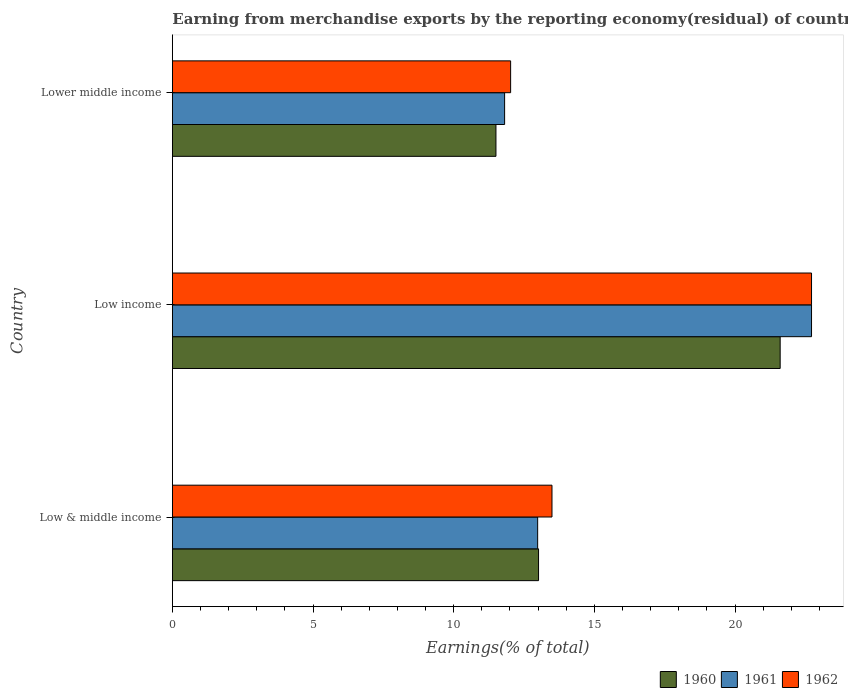How many groups of bars are there?
Give a very brief answer. 3. How many bars are there on the 3rd tick from the bottom?
Give a very brief answer. 3. In how many cases, is the number of bars for a given country not equal to the number of legend labels?
Your response must be concise. 0. What is the percentage of amount earned from merchandise exports in 1962 in Low & middle income?
Ensure brevity in your answer.  13.49. Across all countries, what is the maximum percentage of amount earned from merchandise exports in 1961?
Give a very brief answer. 22.72. Across all countries, what is the minimum percentage of amount earned from merchandise exports in 1962?
Your answer should be compact. 12.02. In which country was the percentage of amount earned from merchandise exports in 1960 minimum?
Offer a terse response. Lower middle income. What is the total percentage of amount earned from merchandise exports in 1961 in the graph?
Ensure brevity in your answer.  47.52. What is the difference between the percentage of amount earned from merchandise exports in 1961 in Low & middle income and that in Lower middle income?
Keep it short and to the point. 1.17. What is the difference between the percentage of amount earned from merchandise exports in 1962 in Low & middle income and the percentage of amount earned from merchandise exports in 1960 in Low income?
Offer a terse response. -8.11. What is the average percentage of amount earned from merchandise exports in 1960 per country?
Your response must be concise. 15.37. What is the difference between the percentage of amount earned from merchandise exports in 1960 and percentage of amount earned from merchandise exports in 1961 in Low & middle income?
Provide a short and direct response. 0.03. What is the ratio of the percentage of amount earned from merchandise exports in 1960 in Low & middle income to that in Low income?
Offer a very short reply. 0.6. Is the percentage of amount earned from merchandise exports in 1961 in Low income less than that in Lower middle income?
Your answer should be compact. No. What is the difference between the highest and the second highest percentage of amount earned from merchandise exports in 1960?
Your answer should be very brief. 8.59. What is the difference between the highest and the lowest percentage of amount earned from merchandise exports in 1960?
Offer a terse response. 10.1. What does the 3rd bar from the top in Lower middle income represents?
Keep it short and to the point. 1960. What does the 1st bar from the bottom in Low income represents?
Provide a short and direct response. 1960. How many bars are there?
Your answer should be compact. 9. What is the difference between two consecutive major ticks on the X-axis?
Provide a succinct answer. 5. Does the graph contain any zero values?
Give a very brief answer. No. Does the graph contain grids?
Your response must be concise. No. Where does the legend appear in the graph?
Make the answer very short. Bottom right. How many legend labels are there?
Offer a terse response. 3. What is the title of the graph?
Offer a very short reply. Earning from merchandise exports by the reporting economy(residual) of countries. What is the label or title of the X-axis?
Your response must be concise. Earnings(% of total). What is the Earnings(% of total) in 1960 in Low & middle income?
Make the answer very short. 13.02. What is the Earnings(% of total) of 1961 in Low & middle income?
Your answer should be very brief. 12.99. What is the Earnings(% of total) in 1962 in Low & middle income?
Provide a short and direct response. 13.49. What is the Earnings(% of total) in 1960 in Low income?
Ensure brevity in your answer.  21.61. What is the Earnings(% of total) of 1961 in Low income?
Provide a succinct answer. 22.72. What is the Earnings(% of total) of 1962 in Low income?
Make the answer very short. 22.72. What is the Earnings(% of total) of 1960 in Lower middle income?
Offer a terse response. 11.5. What is the Earnings(% of total) in 1961 in Lower middle income?
Ensure brevity in your answer.  11.81. What is the Earnings(% of total) of 1962 in Lower middle income?
Make the answer very short. 12.02. Across all countries, what is the maximum Earnings(% of total) in 1960?
Offer a very short reply. 21.61. Across all countries, what is the maximum Earnings(% of total) in 1961?
Offer a very short reply. 22.72. Across all countries, what is the maximum Earnings(% of total) of 1962?
Offer a terse response. 22.72. Across all countries, what is the minimum Earnings(% of total) in 1960?
Make the answer very short. 11.5. Across all countries, what is the minimum Earnings(% of total) in 1961?
Provide a short and direct response. 11.81. Across all countries, what is the minimum Earnings(% of total) in 1962?
Offer a terse response. 12.02. What is the total Earnings(% of total) of 1960 in the graph?
Your answer should be very brief. 46.12. What is the total Earnings(% of total) of 1961 in the graph?
Offer a terse response. 47.52. What is the total Earnings(% of total) in 1962 in the graph?
Your answer should be compact. 48.24. What is the difference between the Earnings(% of total) of 1960 in Low & middle income and that in Low income?
Provide a short and direct response. -8.59. What is the difference between the Earnings(% of total) of 1961 in Low & middle income and that in Low income?
Ensure brevity in your answer.  -9.74. What is the difference between the Earnings(% of total) in 1962 in Low & middle income and that in Low income?
Give a very brief answer. -9.23. What is the difference between the Earnings(% of total) in 1960 in Low & middle income and that in Lower middle income?
Ensure brevity in your answer.  1.51. What is the difference between the Earnings(% of total) of 1961 in Low & middle income and that in Lower middle income?
Offer a terse response. 1.17. What is the difference between the Earnings(% of total) of 1962 in Low & middle income and that in Lower middle income?
Your answer should be compact. 1.47. What is the difference between the Earnings(% of total) of 1960 in Low income and that in Lower middle income?
Your answer should be compact. 10.1. What is the difference between the Earnings(% of total) of 1961 in Low income and that in Lower middle income?
Your answer should be very brief. 10.91. What is the difference between the Earnings(% of total) in 1962 in Low income and that in Lower middle income?
Ensure brevity in your answer.  10.7. What is the difference between the Earnings(% of total) in 1960 in Low & middle income and the Earnings(% of total) in 1961 in Low income?
Give a very brief answer. -9.7. What is the difference between the Earnings(% of total) in 1960 in Low & middle income and the Earnings(% of total) in 1962 in Low income?
Your answer should be compact. -9.7. What is the difference between the Earnings(% of total) in 1961 in Low & middle income and the Earnings(% of total) in 1962 in Low income?
Give a very brief answer. -9.74. What is the difference between the Earnings(% of total) of 1960 in Low & middle income and the Earnings(% of total) of 1961 in Lower middle income?
Make the answer very short. 1.21. What is the difference between the Earnings(% of total) in 1961 in Low & middle income and the Earnings(% of total) in 1962 in Lower middle income?
Your answer should be very brief. 0.96. What is the difference between the Earnings(% of total) of 1960 in Low income and the Earnings(% of total) of 1961 in Lower middle income?
Provide a short and direct response. 9.8. What is the difference between the Earnings(% of total) of 1960 in Low income and the Earnings(% of total) of 1962 in Lower middle income?
Provide a short and direct response. 9.58. What is the difference between the Earnings(% of total) in 1961 in Low income and the Earnings(% of total) in 1962 in Lower middle income?
Your answer should be very brief. 10.7. What is the average Earnings(% of total) of 1960 per country?
Provide a short and direct response. 15.38. What is the average Earnings(% of total) in 1961 per country?
Offer a terse response. 15.84. What is the average Earnings(% of total) of 1962 per country?
Your answer should be very brief. 16.08. What is the difference between the Earnings(% of total) in 1960 and Earnings(% of total) in 1961 in Low & middle income?
Your response must be concise. 0.03. What is the difference between the Earnings(% of total) of 1960 and Earnings(% of total) of 1962 in Low & middle income?
Provide a short and direct response. -0.48. What is the difference between the Earnings(% of total) of 1961 and Earnings(% of total) of 1962 in Low & middle income?
Your answer should be compact. -0.51. What is the difference between the Earnings(% of total) of 1960 and Earnings(% of total) of 1961 in Low income?
Provide a succinct answer. -1.11. What is the difference between the Earnings(% of total) of 1960 and Earnings(% of total) of 1962 in Low income?
Provide a succinct answer. -1.12. What is the difference between the Earnings(% of total) in 1961 and Earnings(% of total) in 1962 in Low income?
Give a very brief answer. -0. What is the difference between the Earnings(% of total) in 1960 and Earnings(% of total) in 1961 in Lower middle income?
Provide a succinct answer. -0.31. What is the difference between the Earnings(% of total) of 1960 and Earnings(% of total) of 1962 in Lower middle income?
Your answer should be compact. -0.52. What is the difference between the Earnings(% of total) of 1961 and Earnings(% of total) of 1962 in Lower middle income?
Make the answer very short. -0.21. What is the ratio of the Earnings(% of total) in 1960 in Low & middle income to that in Low income?
Your answer should be compact. 0.6. What is the ratio of the Earnings(% of total) in 1961 in Low & middle income to that in Low income?
Keep it short and to the point. 0.57. What is the ratio of the Earnings(% of total) of 1962 in Low & middle income to that in Low income?
Provide a short and direct response. 0.59. What is the ratio of the Earnings(% of total) of 1960 in Low & middle income to that in Lower middle income?
Provide a succinct answer. 1.13. What is the ratio of the Earnings(% of total) in 1961 in Low & middle income to that in Lower middle income?
Provide a succinct answer. 1.1. What is the ratio of the Earnings(% of total) in 1962 in Low & middle income to that in Lower middle income?
Keep it short and to the point. 1.12. What is the ratio of the Earnings(% of total) of 1960 in Low income to that in Lower middle income?
Make the answer very short. 1.88. What is the ratio of the Earnings(% of total) in 1961 in Low income to that in Lower middle income?
Your answer should be compact. 1.92. What is the ratio of the Earnings(% of total) of 1962 in Low income to that in Lower middle income?
Your answer should be compact. 1.89. What is the difference between the highest and the second highest Earnings(% of total) of 1960?
Give a very brief answer. 8.59. What is the difference between the highest and the second highest Earnings(% of total) in 1961?
Provide a short and direct response. 9.74. What is the difference between the highest and the second highest Earnings(% of total) in 1962?
Make the answer very short. 9.23. What is the difference between the highest and the lowest Earnings(% of total) in 1960?
Provide a short and direct response. 10.1. What is the difference between the highest and the lowest Earnings(% of total) in 1961?
Give a very brief answer. 10.91. What is the difference between the highest and the lowest Earnings(% of total) in 1962?
Keep it short and to the point. 10.7. 